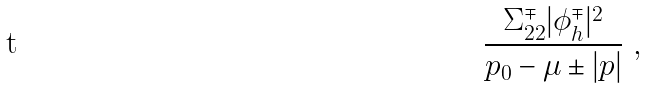Convert formula to latex. <formula><loc_0><loc_0><loc_500><loc_500>\frac { \Sigma _ { 2 2 } ^ { \mp } | \phi ^ { \mp } _ { h } | ^ { 2 } } { p _ { 0 } - \mu \pm | { p } | } \ ,</formula> 